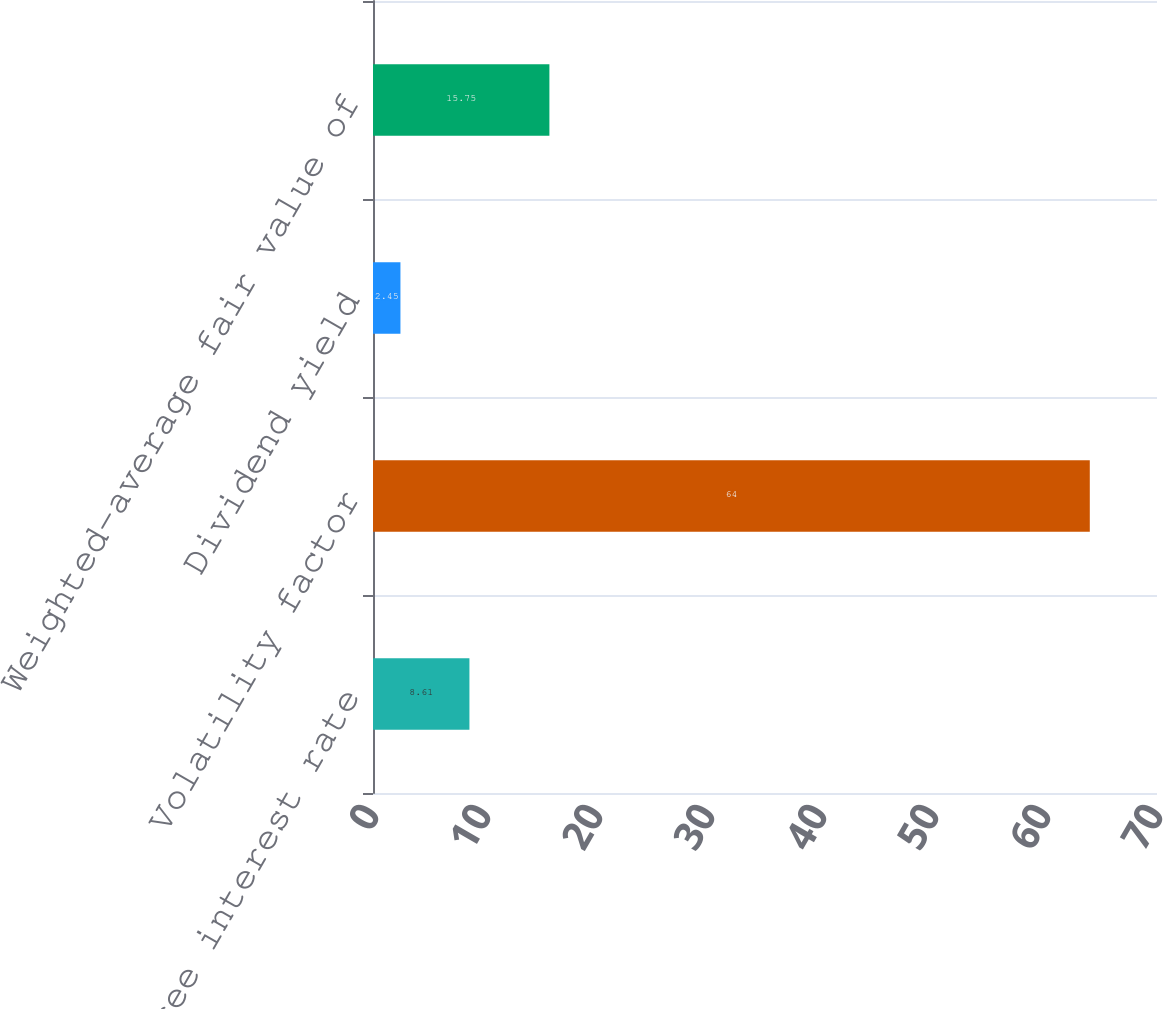Convert chart to OTSL. <chart><loc_0><loc_0><loc_500><loc_500><bar_chart><fcel>Risk-free interest rate<fcel>Volatility factor<fcel>Dividend yield<fcel>Weighted-average fair value of<nl><fcel>8.61<fcel>64<fcel>2.45<fcel>15.75<nl></chart> 